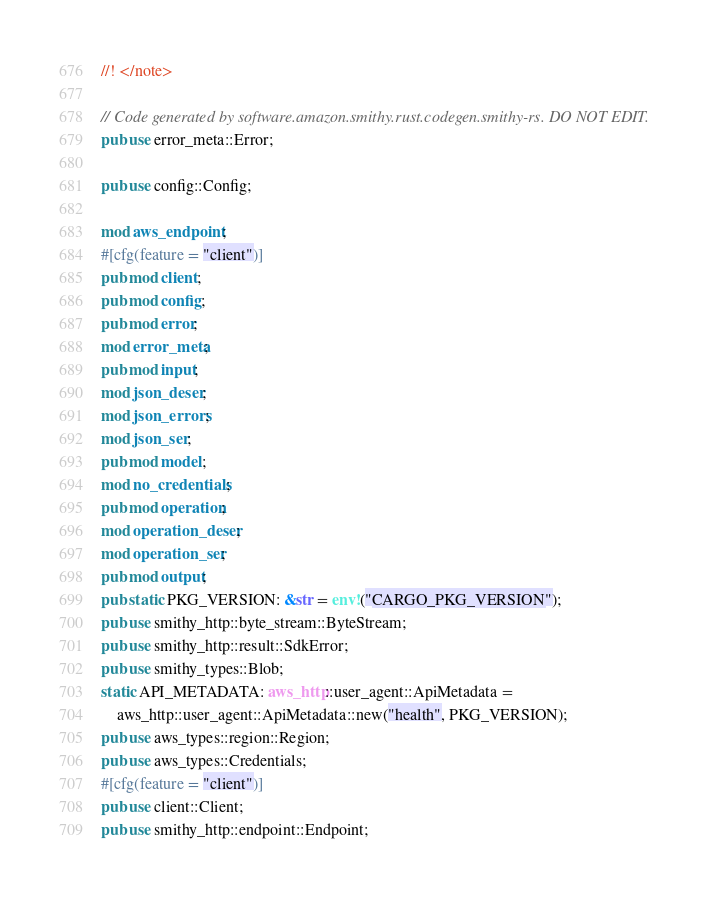Convert code to text. <code><loc_0><loc_0><loc_500><loc_500><_Rust_>//! </note>

// Code generated by software.amazon.smithy.rust.codegen.smithy-rs. DO NOT EDIT.
pub use error_meta::Error;

pub use config::Config;

mod aws_endpoint;
#[cfg(feature = "client")]
pub mod client;
pub mod config;
pub mod error;
mod error_meta;
pub mod input;
mod json_deser;
mod json_errors;
mod json_ser;
pub mod model;
mod no_credentials;
pub mod operation;
mod operation_deser;
mod operation_ser;
pub mod output;
pub static PKG_VERSION: &str = env!("CARGO_PKG_VERSION");
pub use smithy_http::byte_stream::ByteStream;
pub use smithy_http::result::SdkError;
pub use smithy_types::Blob;
static API_METADATA: aws_http::user_agent::ApiMetadata =
    aws_http::user_agent::ApiMetadata::new("health", PKG_VERSION);
pub use aws_types::region::Region;
pub use aws_types::Credentials;
#[cfg(feature = "client")]
pub use client::Client;
pub use smithy_http::endpoint::Endpoint;
</code> 